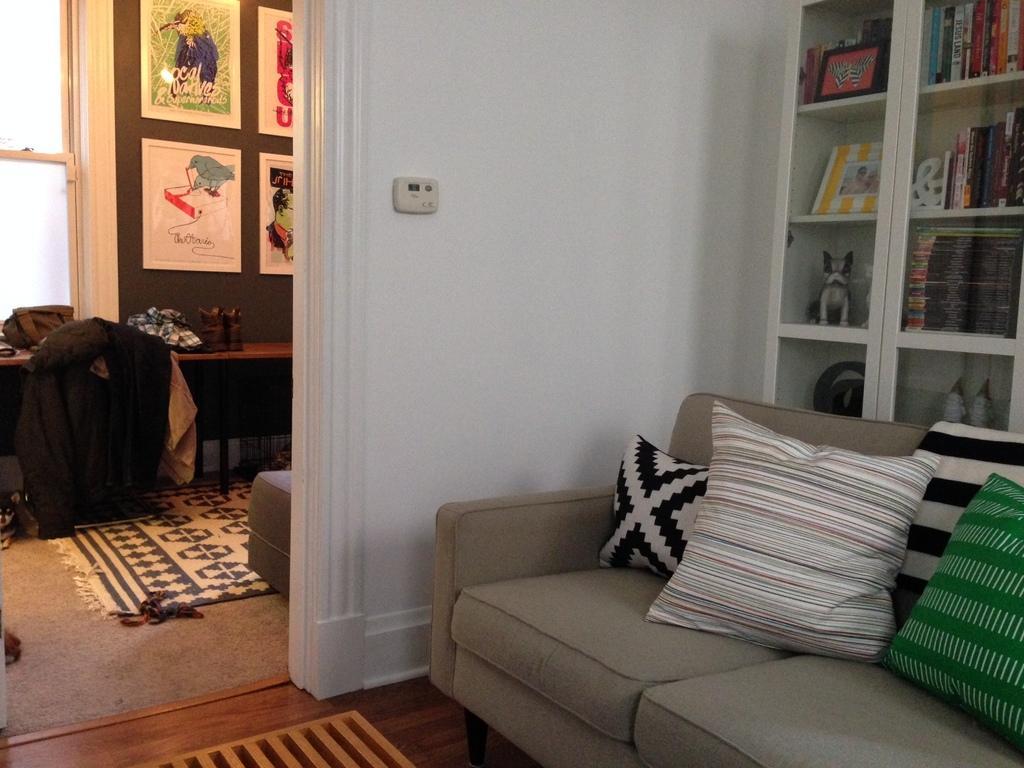Could you give a brief overview of what you see in this image? In this image we can see a sofa with pillows, cupboard, carpet, some things on table and photo frames on the wall. 